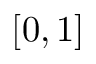Convert formula to latex. <formula><loc_0><loc_0><loc_500><loc_500>[ 0 , 1 ]</formula> 